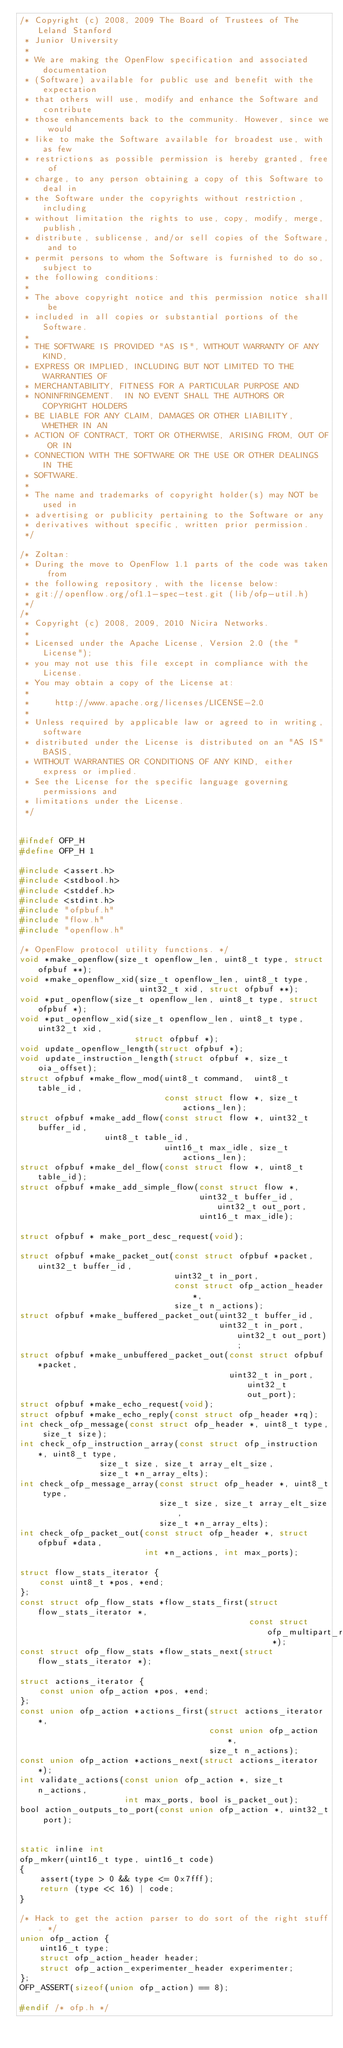Convert code to text. <code><loc_0><loc_0><loc_500><loc_500><_C_>/* Copyright (c) 2008, 2009 The Board of Trustees of The Leland Stanford
 * Junior University
 *
 * We are making the OpenFlow specification and associated documentation
 * (Software) available for public use and benefit with the expectation
 * that others will use, modify and enhance the Software and contribute
 * those enhancements back to the community. However, since we would
 * like to make the Software available for broadest use, with as few
 * restrictions as possible permission is hereby granted, free of
 * charge, to any person obtaining a copy of this Software to deal in
 * the Software under the copyrights without restriction, including
 * without limitation the rights to use, copy, modify, merge, publish,
 * distribute, sublicense, and/or sell copies of the Software, and to
 * permit persons to whom the Software is furnished to do so, subject to
 * the following conditions:
 *
 * The above copyright notice and this permission notice shall be
 * included in all copies or substantial portions of the Software.
 *
 * THE SOFTWARE IS PROVIDED "AS IS", WITHOUT WARRANTY OF ANY KIND,
 * EXPRESS OR IMPLIED, INCLUDING BUT NOT LIMITED TO THE WARRANTIES OF
 * MERCHANTABILITY, FITNESS FOR A PARTICULAR PURPOSE AND
 * NONINFRINGEMENT.  IN NO EVENT SHALL THE AUTHORS OR COPYRIGHT HOLDERS
 * BE LIABLE FOR ANY CLAIM, DAMAGES OR OTHER LIABILITY, WHETHER IN AN
 * ACTION OF CONTRACT, TORT OR OTHERWISE, ARISING FROM, OUT OF OR IN
 * CONNECTION WITH THE SOFTWARE OR THE USE OR OTHER DEALINGS IN THE
 * SOFTWARE.
 *
 * The name and trademarks of copyright holder(s) may NOT be used in
 * advertising or publicity pertaining to the Software or any
 * derivatives without specific, written prior permission.
 */

/* Zoltan:
 * During the move to OpenFlow 1.1 parts of the code was taken from
 * the following repository, with the license below:
 * git://openflow.org/of1.1-spec-test.git (lib/ofp-util.h)
 */
/*
 * Copyright (c) 2008, 2009, 2010 Nicira Networks.
 *
 * Licensed under the Apache License, Version 2.0 (the "License");
 * you may not use this file except in compliance with the License.
 * You may obtain a copy of the License at:
 *
 *     http://www.apache.org/licenses/LICENSE-2.0
 *
 * Unless required by applicable law or agreed to in writing, software
 * distributed under the License is distributed on an "AS IS" BASIS,
 * WITHOUT WARRANTIES OR CONDITIONS OF ANY KIND, either express or implied.
 * See the License for the specific language governing permissions and
 * limitations under the License.
 */


#ifndef OFP_H
#define OFP_H 1

#include <assert.h>
#include <stdbool.h>
#include <stddef.h>
#include <stdint.h>
#include "ofpbuf.h"
#include "flow.h"
#include "openflow.h"

/* OpenFlow protocol utility functions. */
void *make_openflow(size_t openflow_len, uint8_t type, struct ofpbuf **);
void *make_openflow_xid(size_t openflow_len, uint8_t type,
                        uint32_t xid, struct ofpbuf **);
void *put_openflow(size_t openflow_len, uint8_t type, struct ofpbuf *);
void *put_openflow_xid(size_t openflow_len, uint8_t type, uint32_t xid,
                       struct ofpbuf *);
void update_openflow_length(struct ofpbuf *);
void update_instruction_length(struct ofpbuf *, size_t oia_offset);
struct ofpbuf *make_flow_mod(uint8_t command,  uint8_t table_id,
                             const struct flow *, size_t actions_len);
struct ofpbuf *make_add_flow(const struct flow *, uint32_t buffer_id,
			     uint8_t table_id,
                             uint16_t max_idle, size_t actions_len);
struct ofpbuf *make_del_flow(const struct flow *, uint8_t table_id);
struct ofpbuf *make_add_simple_flow(const struct flow *,
                                    uint32_t buffer_id, uint32_t out_port,
                                    uint16_t max_idle);

struct ofpbuf * make_port_desc_request(void);

struct ofpbuf *make_packet_out(const struct ofpbuf *packet, uint32_t buffer_id,
                               uint32_t in_port,
                               const struct ofp_action_header *,
                               size_t n_actions);
struct ofpbuf *make_buffered_packet_out(uint32_t buffer_id,
                                        uint32_t in_port, uint32_t out_port);
struct ofpbuf *make_unbuffered_packet_out(const struct ofpbuf *packet,
                                          uint32_t in_port, uint32_t out_port);
struct ofpbuf *make_echo_request(void);
struct ofpbuf *make_echo_reply(const struct ofp_header *rq);
int check_ofp_message(const struct ofp_header *, uint8_t type, size_t size);
int check_ofp_instruction_array(const struct ofp_instruction *, uint8_t type,
				size_t size, size_t array_elt_size,
				size_t *n_array_elts);
int check_ofp_message_array(const struct ofp_header *, uint8_t type,
                            size_t size, size_t array_elt_size,
                            size_t *n_array_elts);
int check_ofp_packet_out(const struct ofp_header *, struct ofpbuf *data,
                         int *n_actions, int max_ports);

struct flow_stats_iterator {
    const uint8_t *pos, *end;
};
const struct ofp_flow_stats *flow_stats_first(struct flow_stats_iterator *,
                                              const struct ofp_multipart_reply *);
const struct ofp_flow_stats *flow_stats_next(struct flow_stats_iterator *);

struct actions_iterator {
    const union ofp_action *pos, *end;
};
const union ofp_action *actions_first(struct actions_iterator *,
                                      const union ofp_action *,
                                      size_t n_actions);
const union ofp_action *actions_next(struct actions_iterator *);
int validate_actions(const union ofp_action *, size_t n_actions,
                     int max_ports, bool is_packet_out);
bool action_outputs_to_port(const union ofp_action *, uint32_t port);


static inline int
ofp_mkerr(uint16_t type, uint16_t code)
{
    assert(type > 0 && type <= 0x7fff);
    return (type << 16) | code;
}

/* Hack to get the action parser to do sort of the right stuff. */
union ofp_action {
    uint16_t type;
    struct ofp_action_header header;
    struct ofp_action_experimenter_header experimenter;
};
OFP_ASSERT(sizeof(union ofp_action) == 8);

#endif /* ofp.h */
</code> 